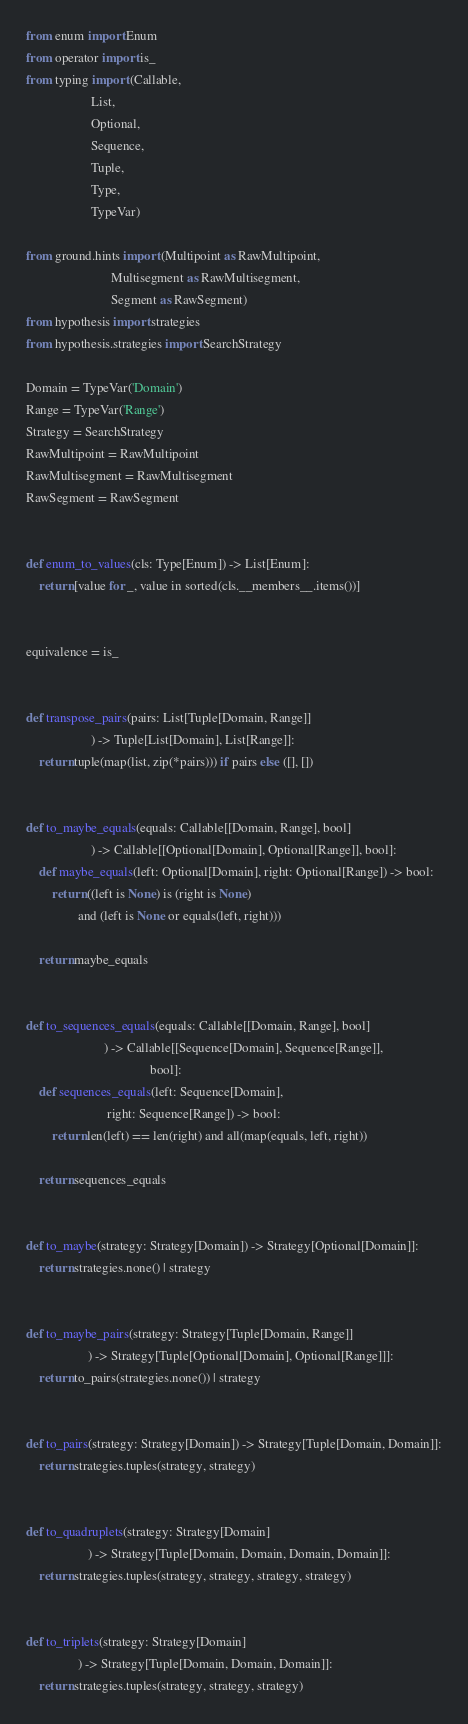Convert code to text. <code><loc_0><loc_0><loc_500><loc_500><_Python_>from enum import Enum
from operator import is_
from typing import (Callable,
                    List,
                    Optional,
                    Sequence,
                    Tuple,
                    Type,
                    TypeVar)

from ground.hints import (Multipoint as RawMultipoint,
                          Multisegment as RawMultisegment,
                          Segment as RawSegment)
from hypothesis import strategies
from hypothesis.strategies import SearchStrategy

Domain = TypeVar('Domain')
Range = TypeVar('Range')
Strategy = SearchStrategy
RawMultipoint = RawMultipoint
RawMultisegment = RawMultisegment
RawSegment = RawSegment


def enum_to_values(cls: Type[Enum]) -> List[Enum]:
    return [value for _, value in sorted(cls.__members__.items())]


equivalence = is_


def transpose_pairs(pairs: List[Tuple[Domain, Range]]
                    ) -> Tuple[List[Domain], List[Range]]:
    return tuple(map(list, zip(*pairs))) if pairs else ([], [])


def to_maybe_equals(equals: Callable[[Domain, Range], bool]
                    ) -> Callable[[Optional[Domain], Optional[Range]], bool]:
    def maybe_equals(left: Optional[Domain], right: Optional[Range]) -> bool:
        return ((left is None) is (right is None)
                and (left is None or equals(left, right)))

    return maybe_equals


def to_sequences_equals(equals: Callable[[Domain, Range], bool]
                        ) -> Callable[[Sequence[Domain], Sequence[Range]],
                                      bool]:
    def sequences_equals(left: Sequence[Domain],
                         right: Sequence[Range]) -> bool:
        return len(left) == len(right) and all(map(equals, left, right))

    return sequences_equals


def to_maybe(strategy: Strategy[Domain]) -> Strategy[Optional[Domain]]:
    return strategies.none() | strategy


def to_maybe_pairs(strategy: Strategy[Tuple[Domain, Range]]
                   ) -> Strategy[Tuple[Optional[Domain], Optional[Range]]]:
    return to_pairs(strategies.none()) | strategy


def to_pairs(strategy: Strategy[Domain]) -> Strategy[Tuple[Domain, Domain]]:
    return strategies.tuples(strategy, strategy)


def to_quadruplets(strategy: Strategy[Domain]
                   ) -> Strategy[Tuple[Domain, Domain, Domain, Domain]]:
    return strategies.tuples(strategy, strategy, strategy, strategy)


def to_triplets(strategy: Strategy[Domain]
                ) -> Strategy[Tuple[Domain, Domain, Domain]]:
    return strategies.tuples(strategy, strategy, strategy)
</code> 